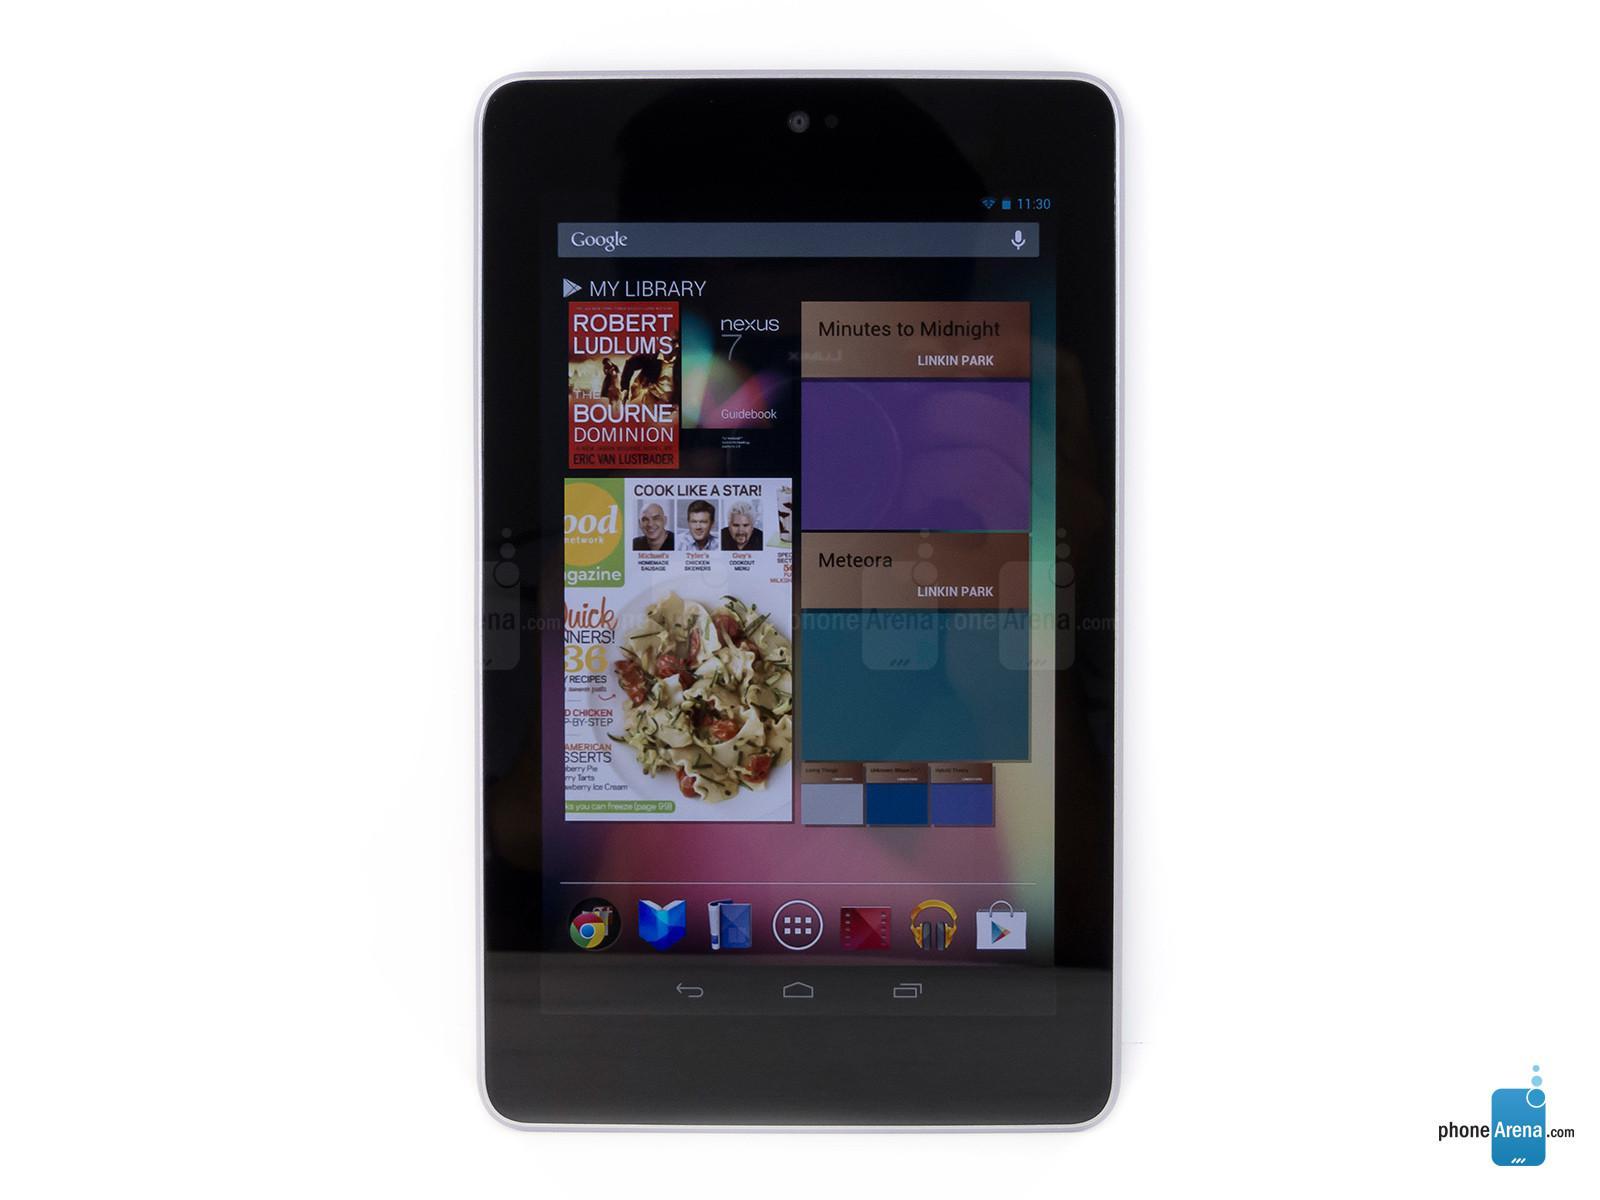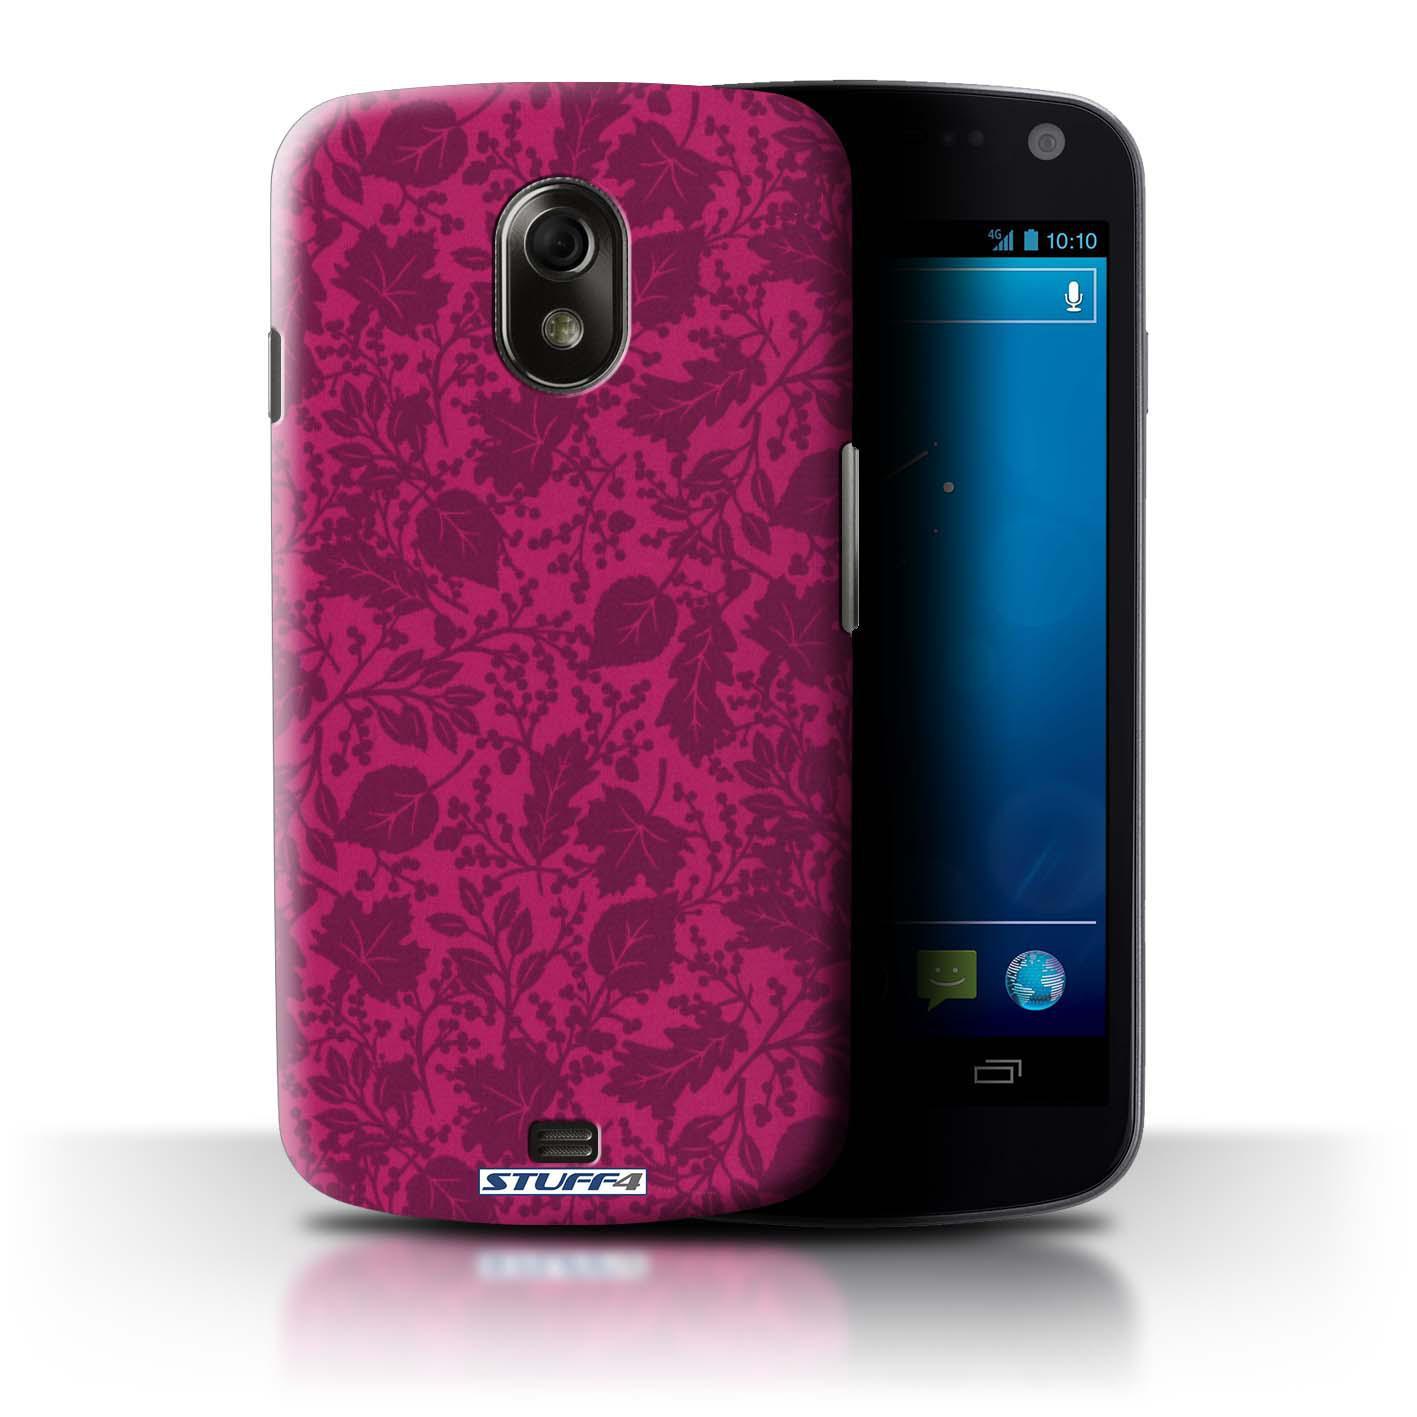The first image is the image on the left, the second image is the image on the right. Given the left and right images, does the statement "There are no less than five phones." hold true? Answer yes or no. No. The first image is the image on the left, the second image is the image on the right. Analyze the images presented: Is the assertion "There is no less than five phones." valid? Answer yes or no. No. 